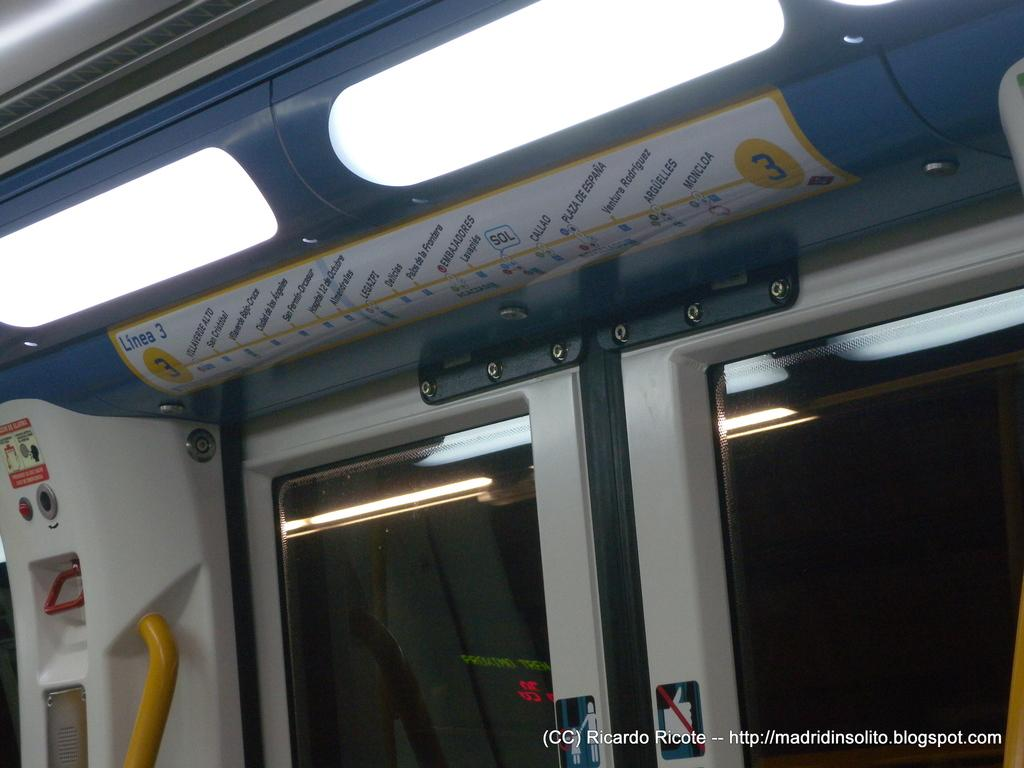What type of vehicle is the image taken from? The image is taken from inside a metro train. Where are the doors located in the image? The doors are on the right side of the image. What is displayed at the top of the image? There is a map and lights at the top of the image. What information can be found in the bottom right corner of the image? There is text in the bottom right corner of the image. Can you see someone attempting to jump over the metro train in the image? No, there is no one attempting to jump over the metro train in the image. Is there any steam coming out of the metro train in the image? No, there is no steam visible in the image. 